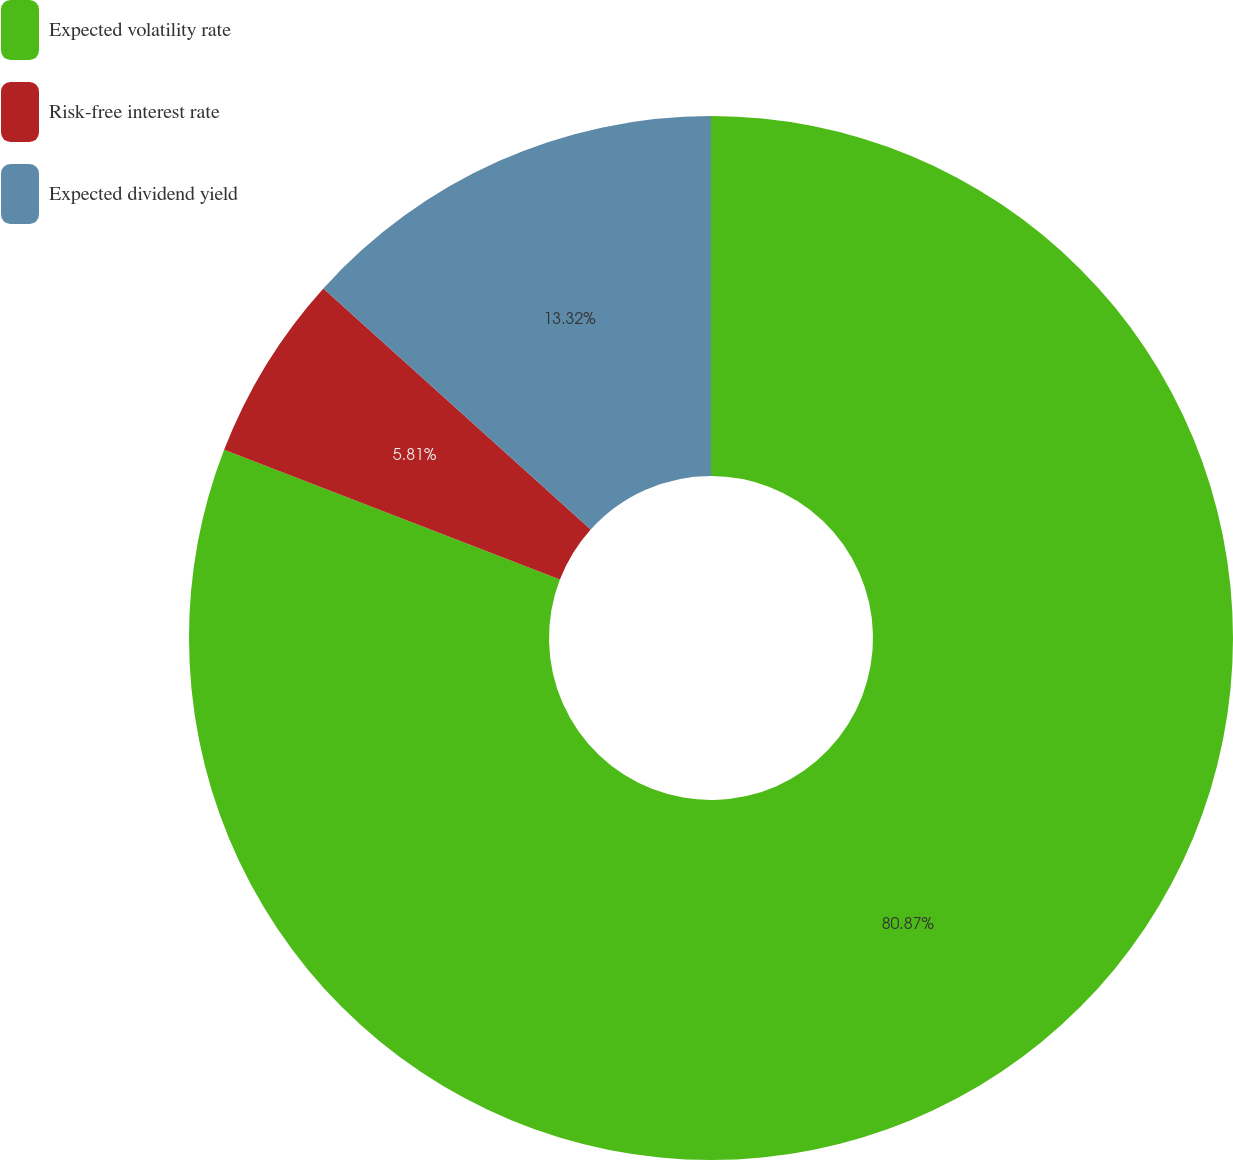Convert chart. <chart><loc_0><loc_0><loc_500><loc_500><pie_chart><fcel>Expected volatility rate<fcel>Risk-free interest rate<fcel>Expected dividend yield<nl><fcel>80.87%<fcel>5.81%<fcel>13.32%<nl></chart> 